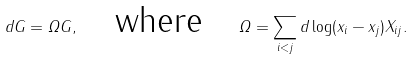<formula> <loc_0><loc_0><loc_500><loc_500>d G = \varOmega G , \quad \text {where} \quad \varOmega = \sum _ { i < j } d \log ( x _ { i } - x _ { j } ) X _ { i j } .</formula> 